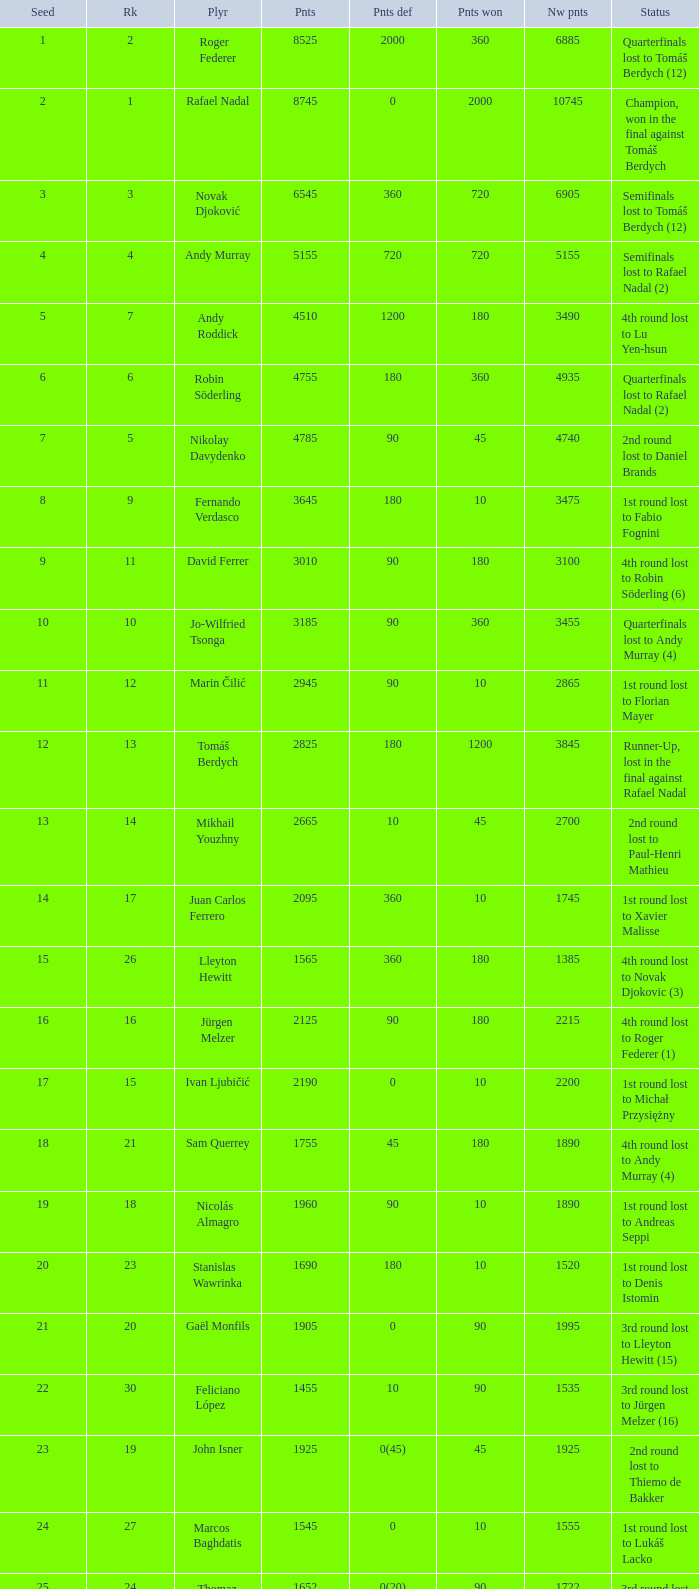Name the number of points defending for 1075 1.0. 